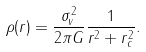Convert formula to latex. <formula><loc_0><loc_0><loc_500><loc_500>\rho ( r ) = \frac { \sigma _ { v } ^ { 2 } } { 2 \pi G } \frac { 1 } { r ^ { 2 } + r _ { c } ^ { 2 } } .</formula> 